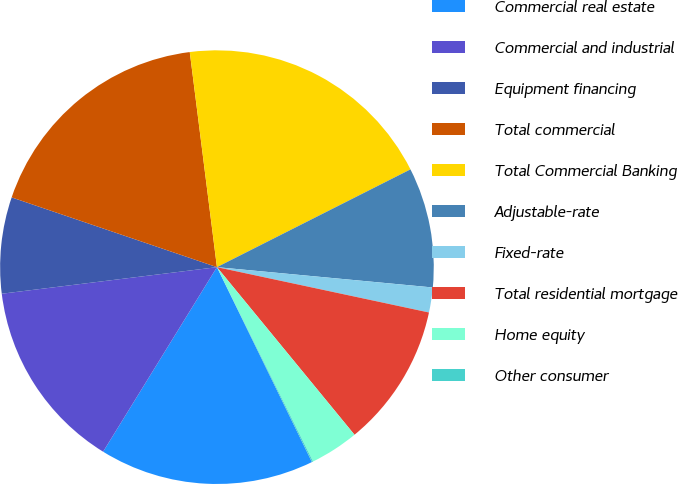Convert chart to OTSL. <chart><loc_0><loc_0><loc_500><loc_500><pie_chart><fcel>Commercial real estate<fcel>Commercial and industrial<fcel>Equipment financing<fcel>Total commercial<fcel>Total Commercial Banking<fcel>Adjustable-rate<fcel>Fixed-rate<fcel>Total residential mortgage<fcel>Home equity<fcel>Other consumer<nl><fcel>16.02%<fcel>14.25%<fcel>7.17%<fcel>17.79%<fcel>19.56%<fcel>8.94%<fcel>1.86%<fcel>10.71%<fcel>3.63%<fcel>0.09%<nl></chart> 